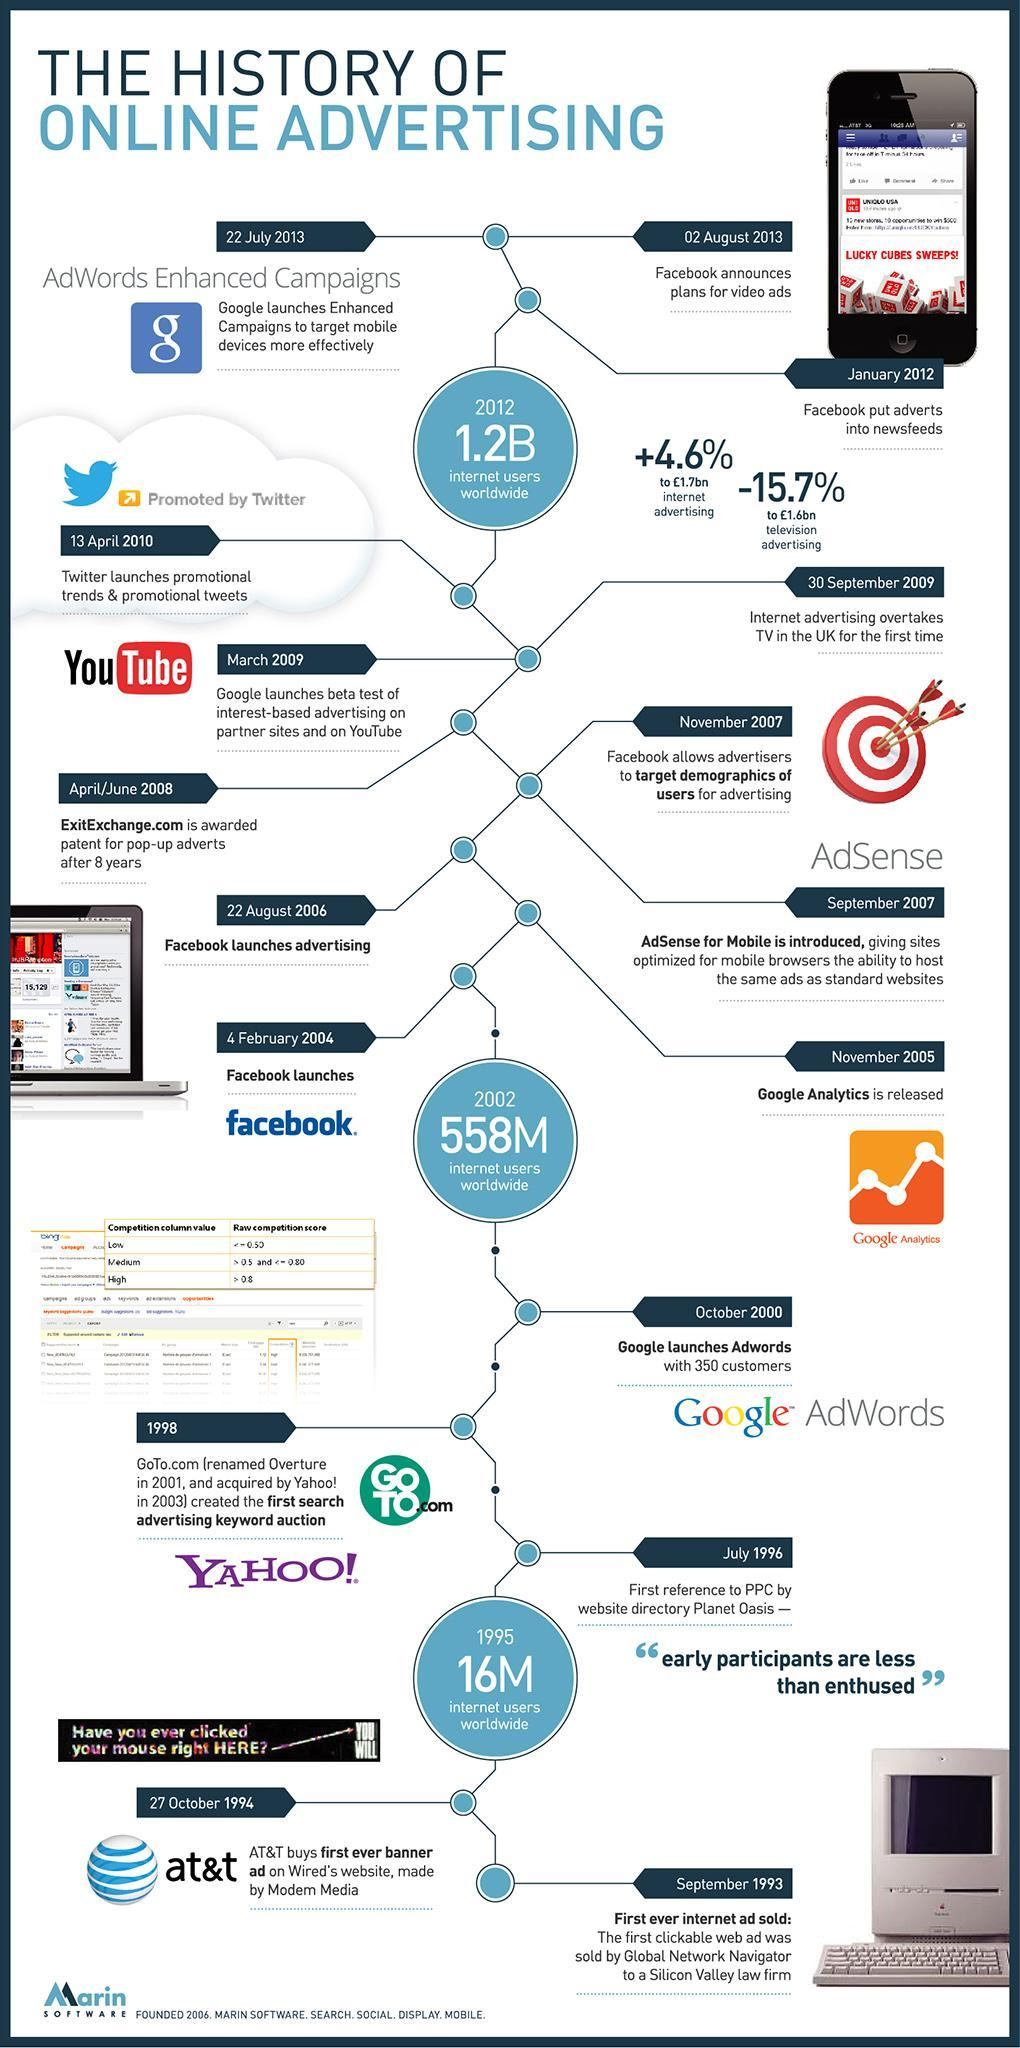When was the Facebook introduced?
Answer the question with a short phrase. 4 February 2004 What was the internet user population in the world in 2002? 558M 